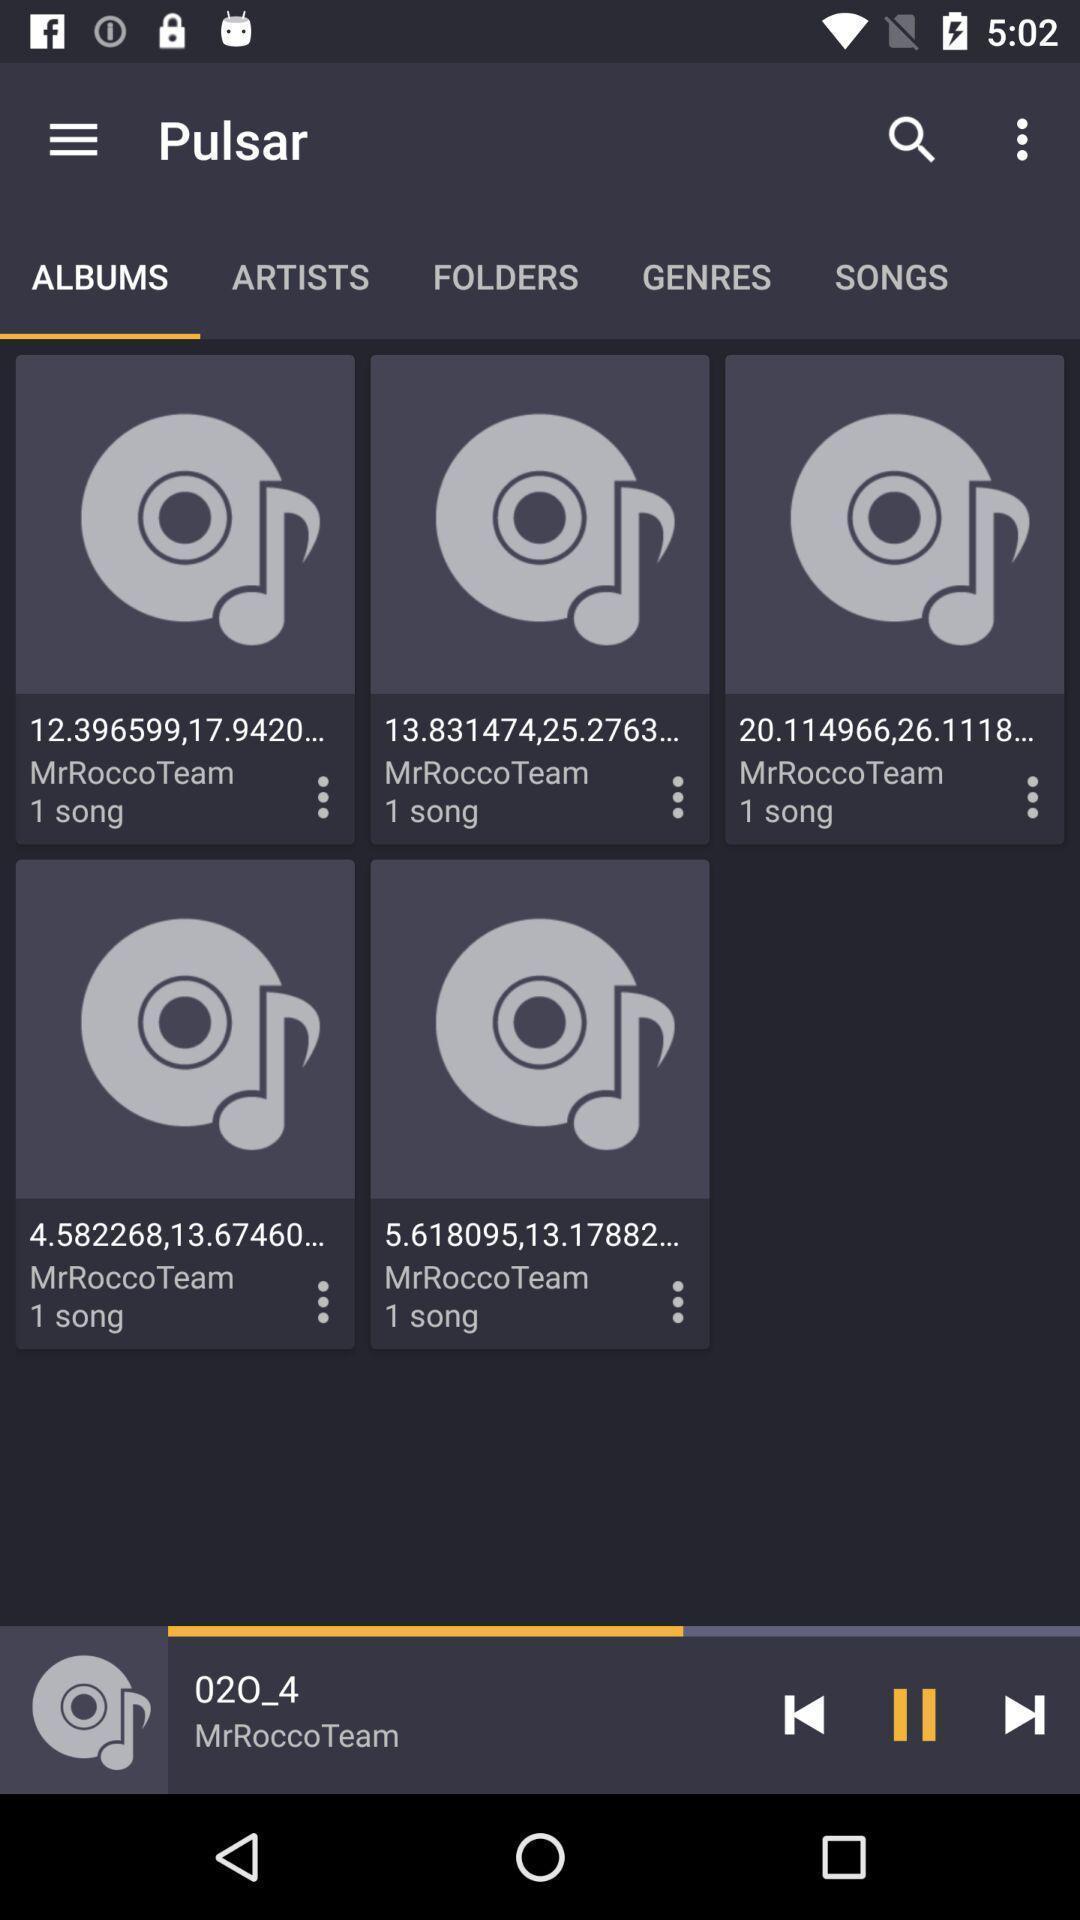Describe the visual elements of this screenshot. Screen showing albums in an music application. 